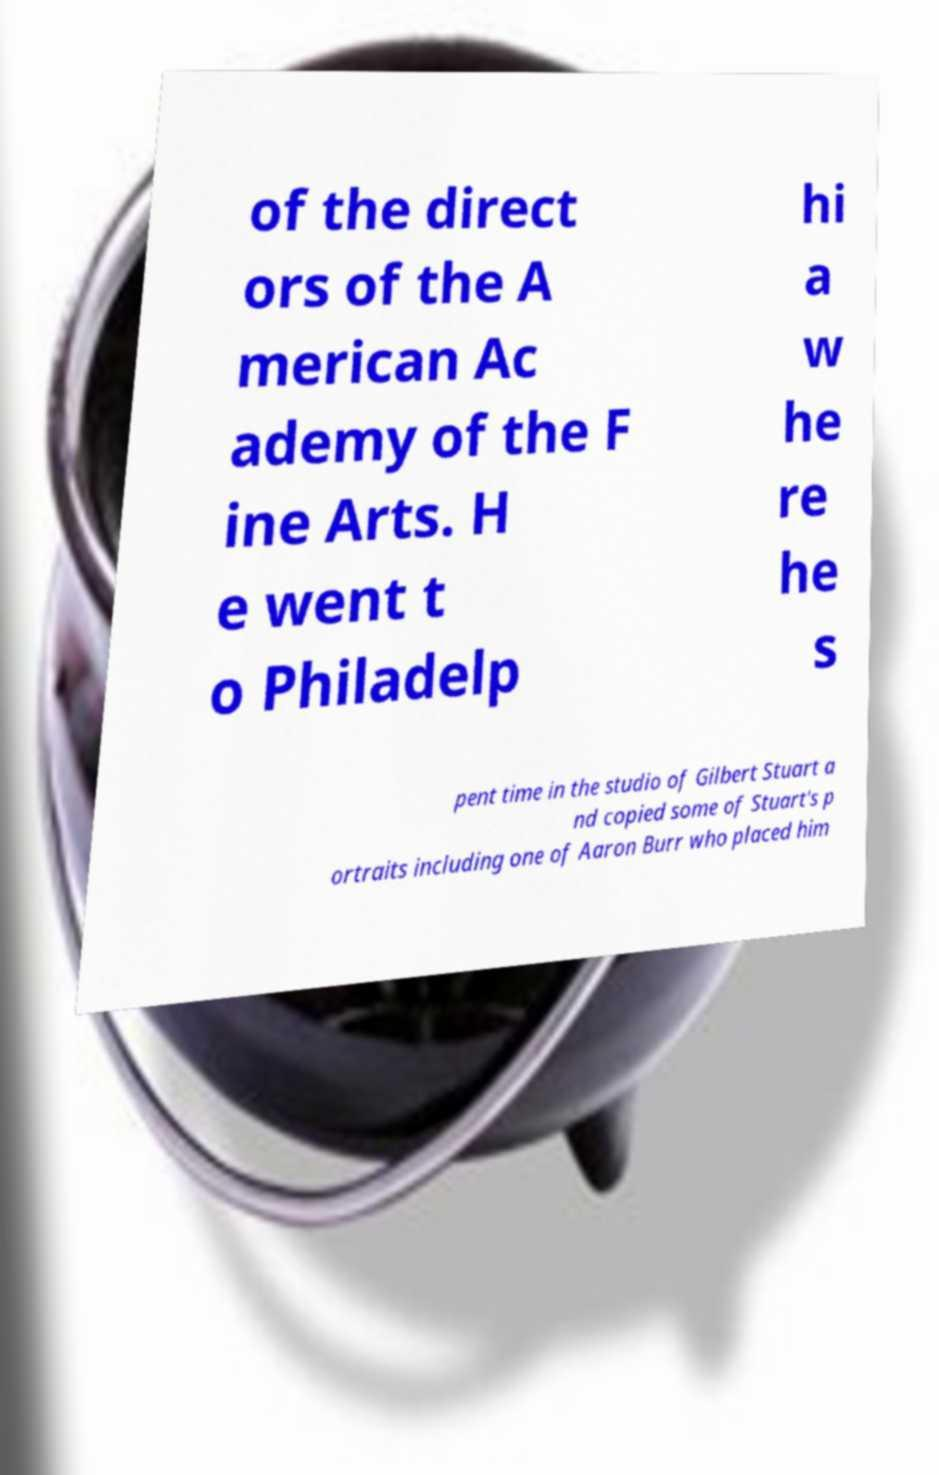Can you read and provide the text displayed in the image?This photo seems to have some interesting text. Can you extract and type it out for me? of the direct ors of the A merican Ac ademy of the F ine Arts. H e went t o Philadelp hi a w he re he s pent time in the studio of Gilbert Stuart a nd copied some of Stuart's p ortraits including one of Aaron Burr who placed him 